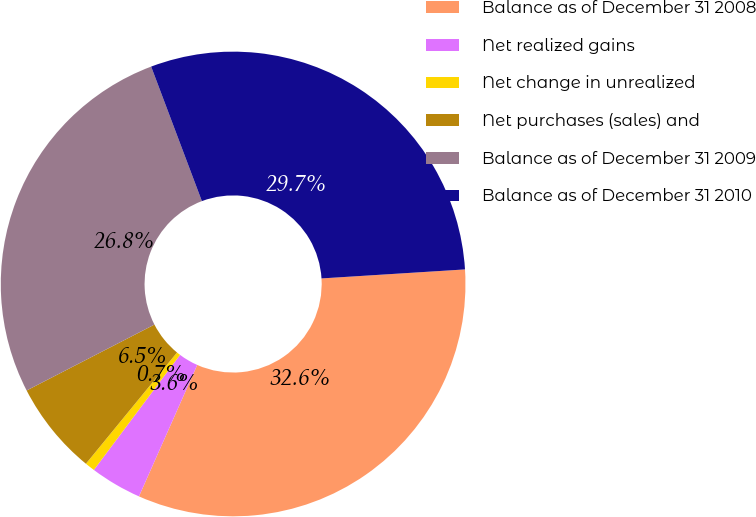Convert chart. <chart><loc_0><loc_0><loc_500><loc_500><pie_chart><fcel>Balance as of December 31 2008<fcel>Net realized gains<fcel>Net change in unrealized<fcel>Net purchases (sales) and<fcel>Balance as of December 31 2009<fcel>Balance as of December 31 2010<nl><fcel>32.64%<fcel>3.59%<fcel>0.69%<fcel>6.5%<fcel>26.84%<fcel>29.74%<nl></chart> 